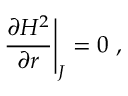Convert formula to latex. <formula><loc_0><loc_0><loc_500><loc_500>{ \frac { \partial H ^ { 2 } } { \partial r } } \Big | _ { J } = 0 \ ,</formula> 